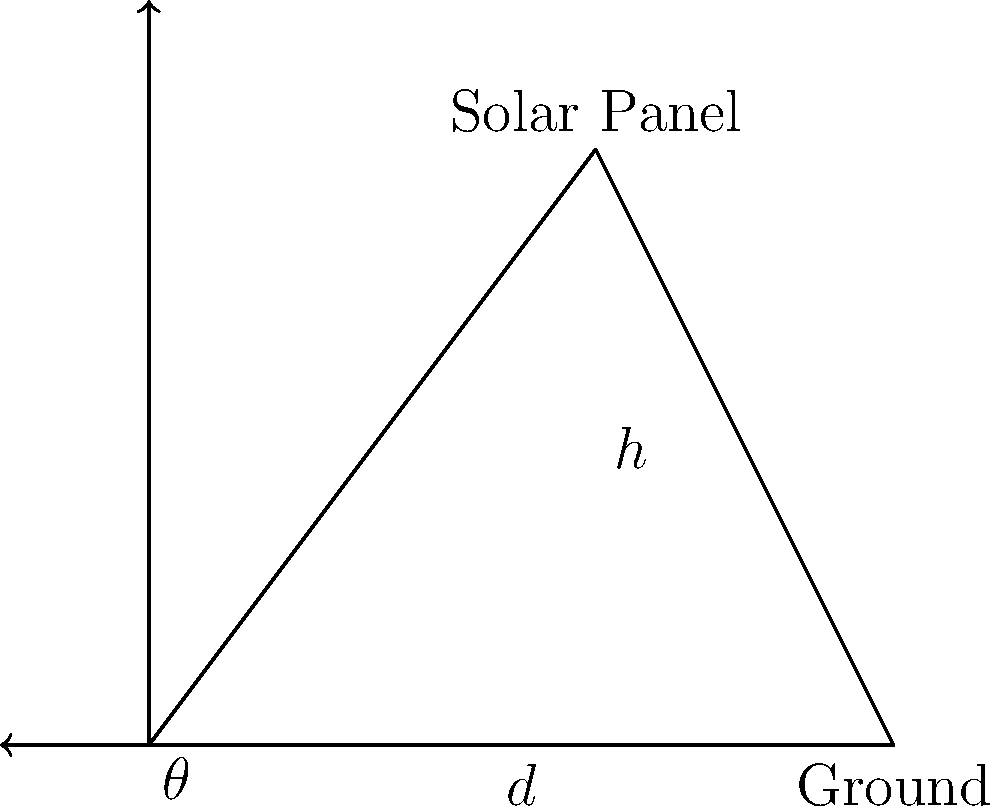As a real estate agent, you're advising a client on installing solar panels on their roof. The solar panel's efficiency is directly related to its angle of installation. If the panel is $5$ meters long and mounted at an angle $\theta$ such that its height above the ground is $4$ meters, what is the angle $\theta$ in degrees? Round your answer to the nearest whole number. Let's approach this step-by-step:

1) We can treat the solar panel as the hypotenuse of a right-angled triangle.

2) We know:
   - The length of the panel (hypotenuse) is $5$ meters
   - The height ($h$) is $4$ meters

3) We need to find the angle $\theta$. We can use the inverse sine function (arcsin) for this.

4) In a right-angled triangle, $\sin(\theta) = \frac{\text{opposite}}{\text{hypotenuse}}$

5) In this case: $\sin(\theta) = \frac{h}{\text{panel length}} = \frac{4}{5}$

6) Therefore, $\theta = \arcsin(\frac{4}{5})$

7) Using a calculator (or programming function):
   $\theta \approx 53.13010235415598$ degrees

8) Rounding to the nearest whole number: $53$ degrees
Answer: $53$ degrees 